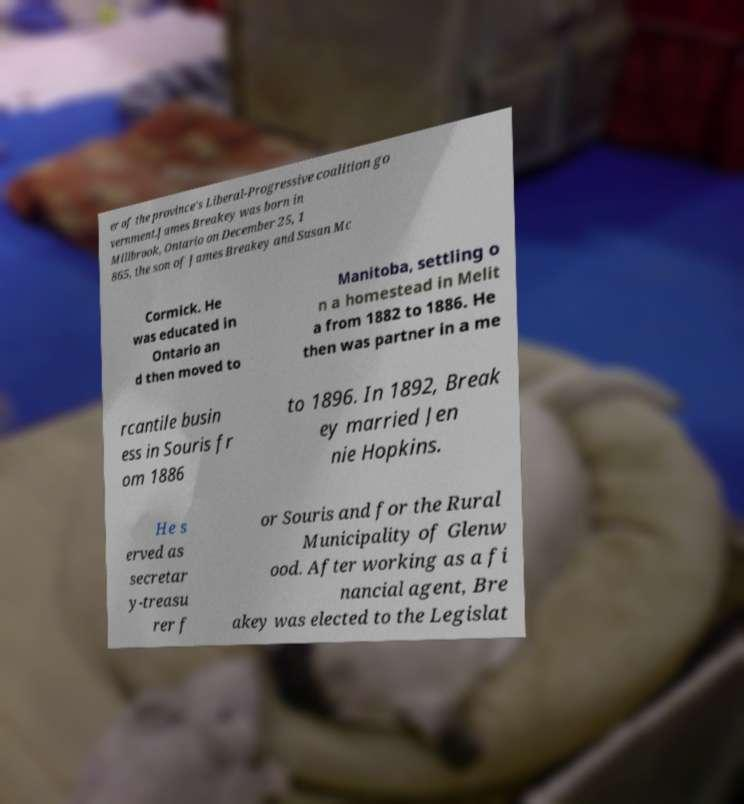What messages or text are displayed in this image? I need them in a readable, typed format. er of the province's Liberal-Progressive coalition go vernment.James Breakey was born in Millbrook, Ontario on December 25, 1 865, the son of James Breakey and Susan Mc Cormick. He was educated in Ontario an d then moved to Manitoba, settling o n a homestead in Melit a from 1882 to 1886. He then was partner in a me rcantile busin ess in Souris fr om 1886 to 1896. In 1892, Break ey married Jen nie Hopkins. He s erved as secretar y-treasu rer f or Souris and for the Rural Municipality of Glenw ood. After working as a fi nancial agent, Bre akey was elected to the Legislat 